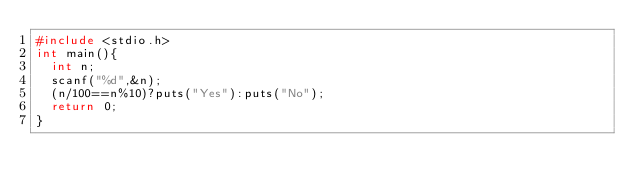<code> <loc_0><loc_0><loc_500><loc_500><_C_>#include <stdio.h>
int main(){
  int n;
  scanf("%d",&n);
  (n/100==n%10)?puts("Yes"):puts("No");
  return 0;
}
</code> 